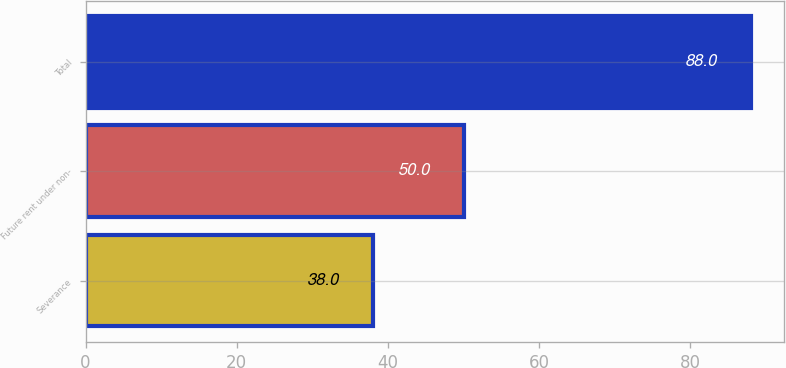<chart> <loc_0><loc_0><loc_500><loc_500><bar_chart><fcel>Severance<fcel>Future rent under non-<fcel>Total<nl><fcel>38<fcel>50<fcel>88<nl></chart> 